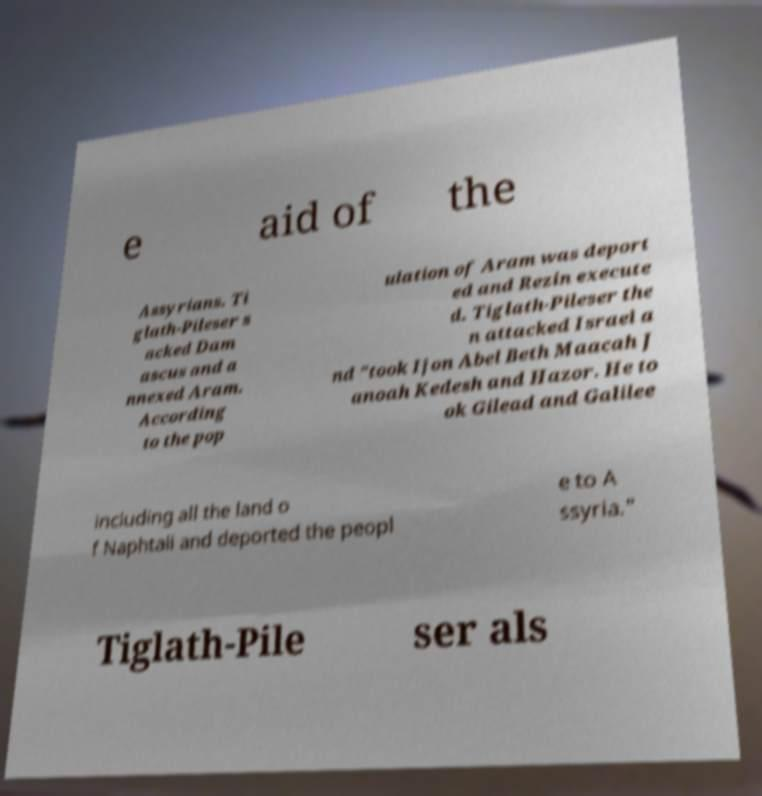Can you read and provide the text displayed in the image?This photo seems to have some interesting text. Can you extract and type it out for me? e aid of the Assyrians. Ti glath-Pileser s acked Dam ascus and a nnexed Aram. According to the pop ulation of Aram was deport ed and Rezin execute d. Tiglath-Pileser the n attacked Israel a nd "took Ijon Abel Beth Maacah J anoah Kedesh and Hazor. He to ok Gilead and Galilee including all the land o f Naphtali and deported the peopl e to A ssyria." Tiglath-Pile ser als 